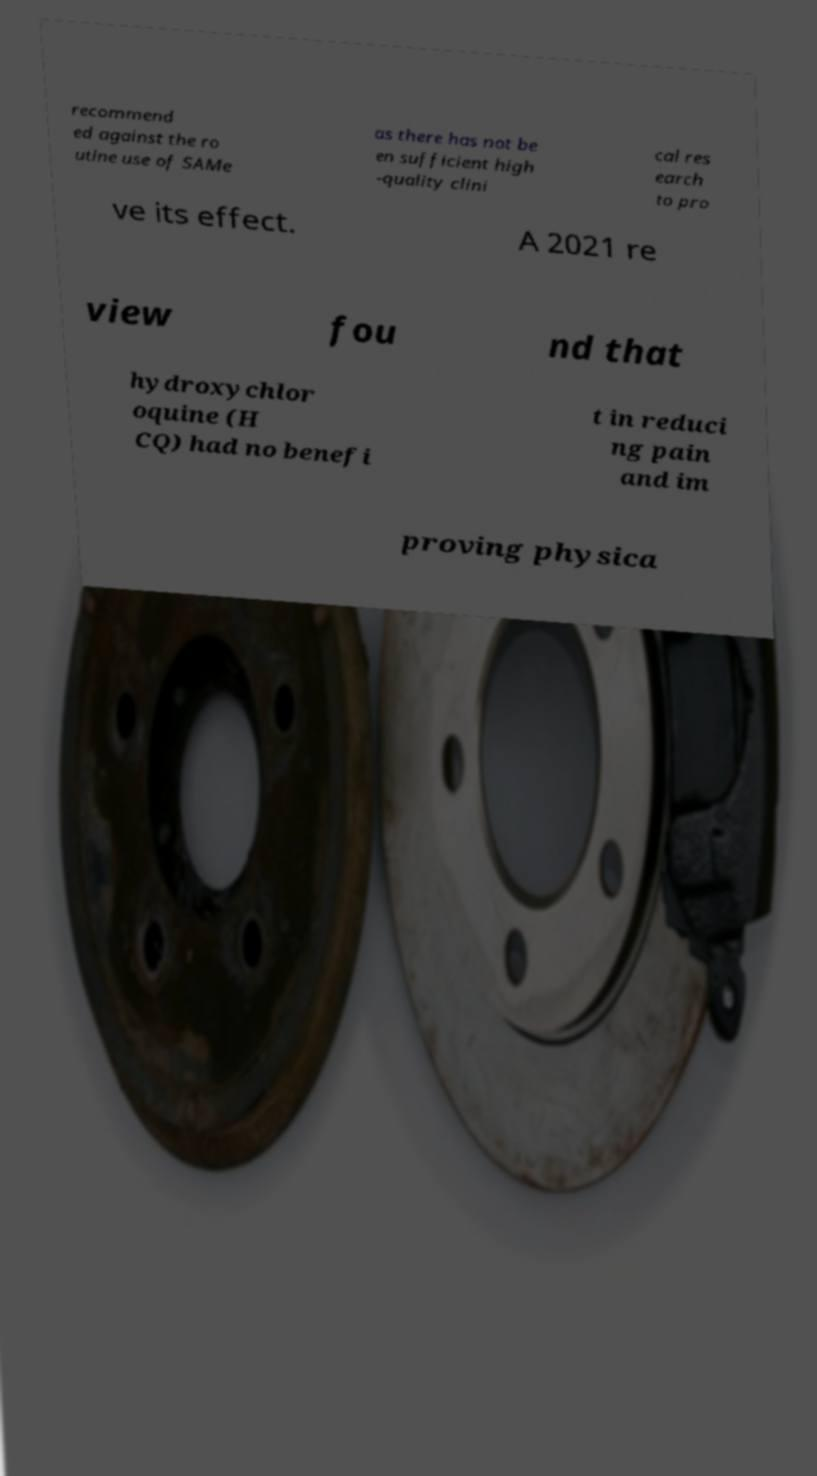What messages or text are displayed in this image? I need them in a readable, typed format. recommend ed against the ro utine use of SAMe as there has not be en sufficient high -quality clini cal res earch to pro ve its effect. A 2021 re view fou nd that hydroxychlor oquine (H CQ) had no benefi t in reduci ng pain and im proving physica 